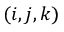<formula> <loc_0><loc_0><loc_500><loc_500>( i , j , k )</formula> 